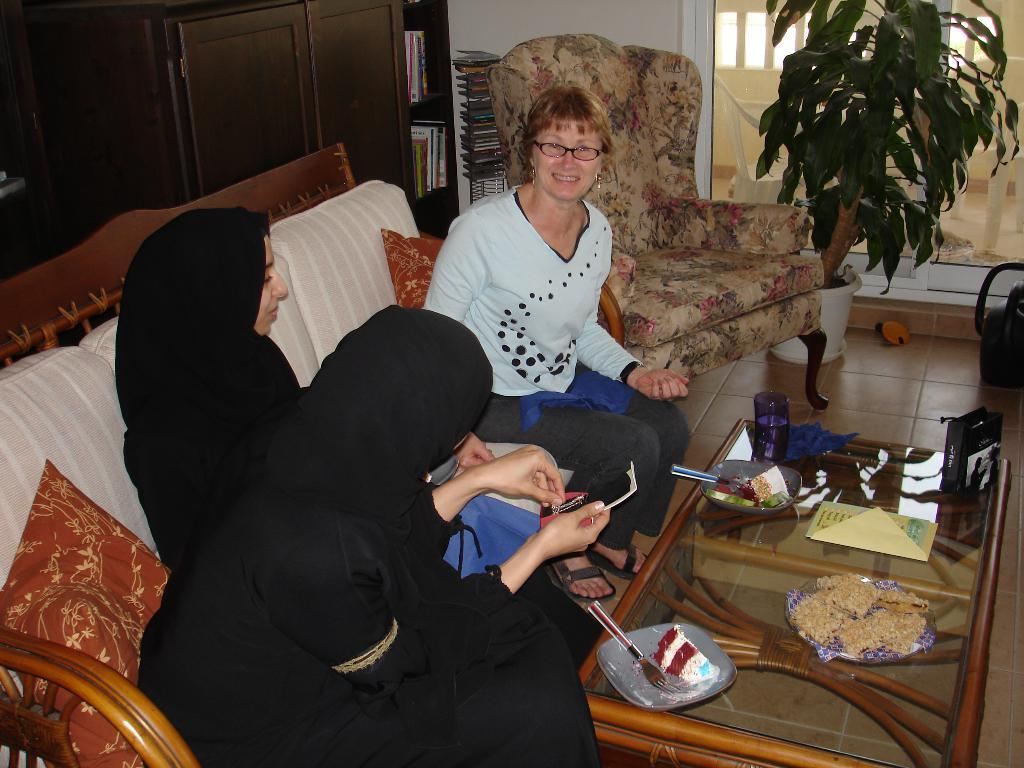What are the people in the image doing? People are sitting on the sofa in the image. Where is the sofa located in relation to the table? The sofa is near a table in the image. What items can be seen on the table? Food, folk, and plates are present on the table in the image. What can be seen in the background of the image? In the background, there is a plant, a glass, and a shelf with books. How many ladybugs are crawling on the bookshelf in the image? There are no ladybugs present on the bookshelf or in the image. What type of force is being applied to the table in the image? There is no indication of any force being applied to the table in the image. 